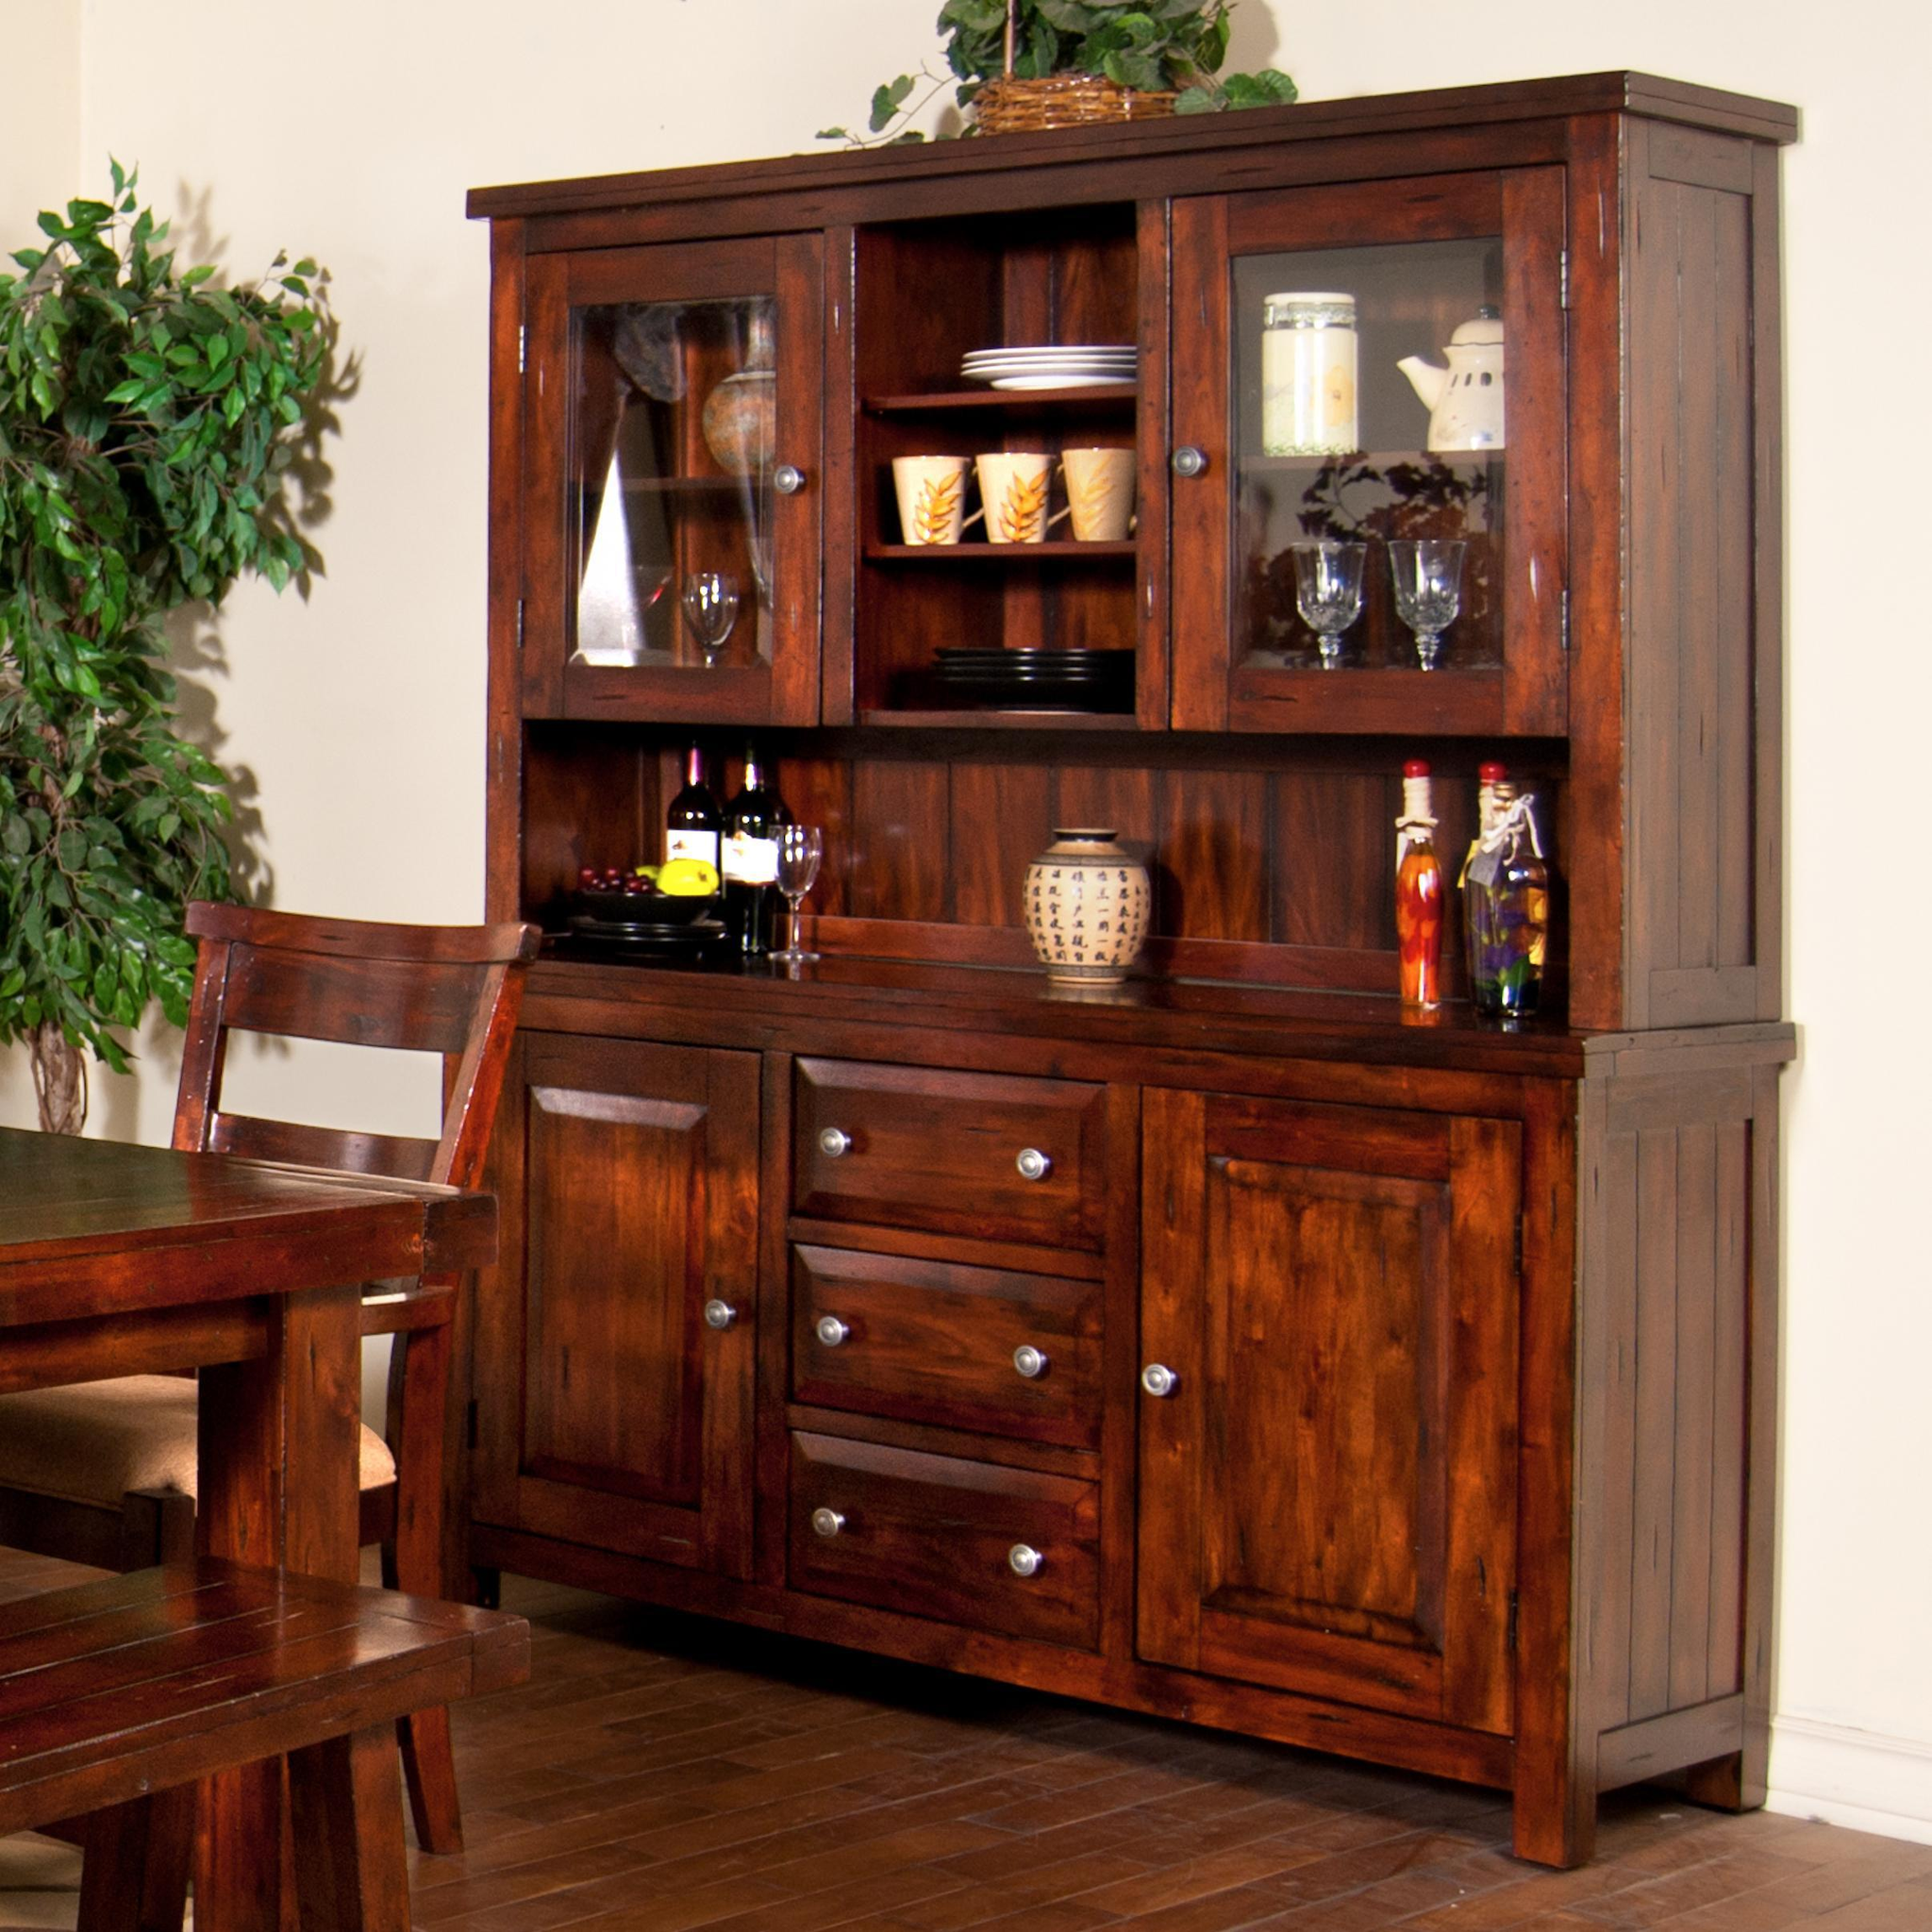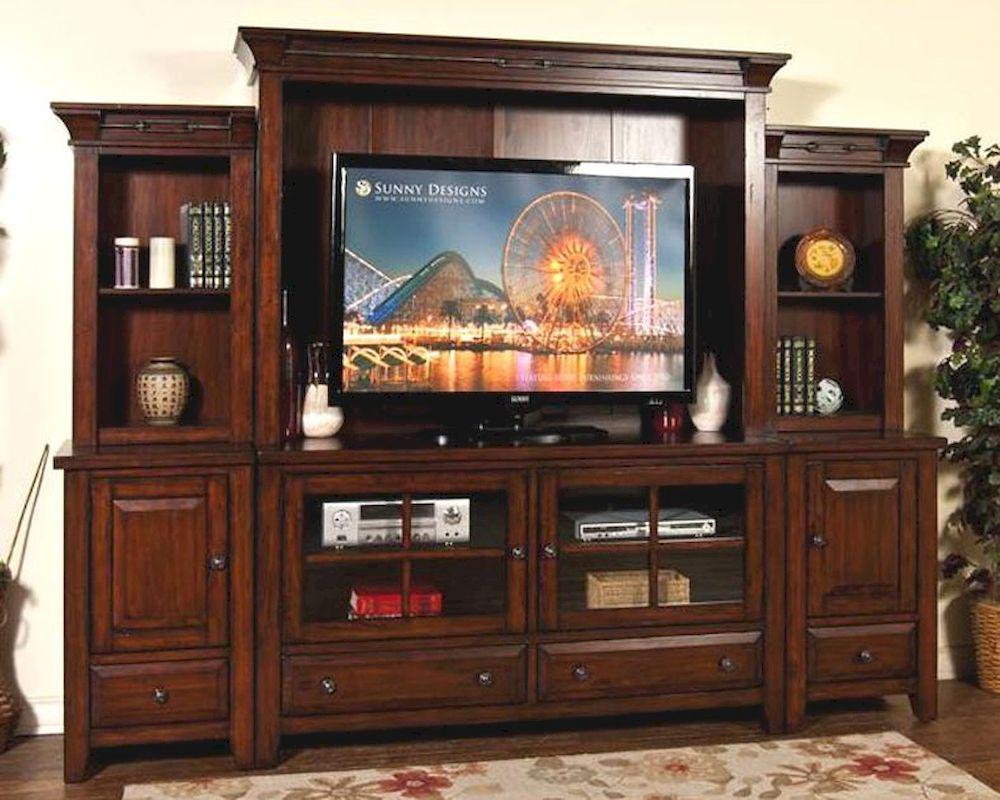The first image is the image on the left, the second image is the image on the right. For the images shown, is this caption "A brown wooden hutch has a flat top that extends beyond the cabinet, sits on short legs, and has been repurposed in the center bottom section to make a wine rack." true? Answer yes or no. No. The first image is the image on the left, the second image is the image on the right. Examine the images to the left and right. Is the description "In one image there is a single white Kitchen storage unit  that holds white bowls and cups." accurate? Answer yes or no. No. The first image is the image on the left, the second image is the image on the right. Examine the images to the left and right. Is the description "The right image contains a white china cabinet with glass doors." accurate? Answer yes or no. No. 